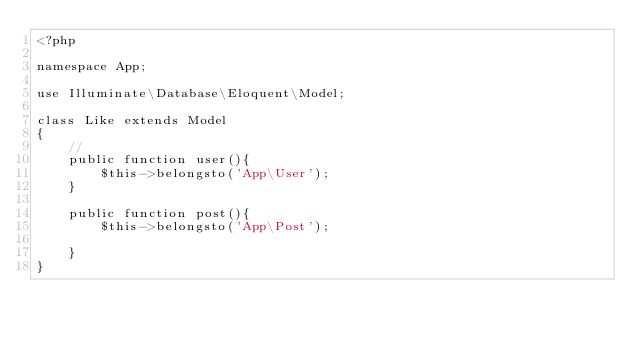Convert code to text. <code><loc_0><loc_0><loc_500><loc_500><_PHP_><?php

namespace App;

use Illuminate\Database\Eloquent\Model;

class Like extends Model
{
    //
    public function user(){
        $this->belongsto('App\User');
    }

    public function post(){
        $this->belongsto('App\Post');

    }
}
</code> 